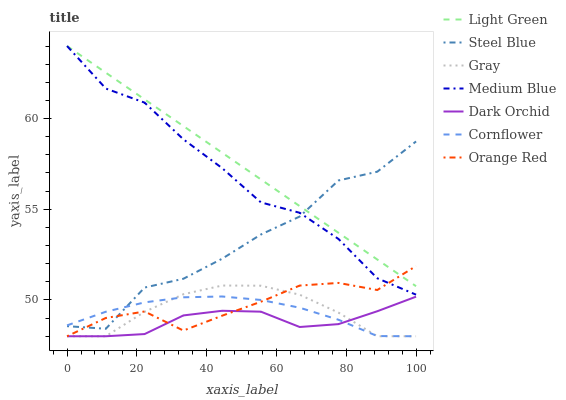Does Dark Orchid have the minimum area under the curve?
Answer yes or no. Yes. Does Light Green have the maximum area under the curve?
Answer yes or no. Yes. Does Cornflower have the minimum area under the curve?
Answer yes or no. No. Does Cornflower have the maximum area under the curve?
Answer yes or no. No. Is Light Green the smoothest?
Answer yes or no. Yes. Is Steel Blue the roughest?
Answer yes or no. Yes. Is Cornflower the smoothest?
Answer yes or no. No. Is Cornflower the roughest?
Answer yes or no. No. Does Gray have the lowest value?
Answer yes or no. Yes. Does Medium Blue have the lowest value?
Answer yes or no. No. Does Light Green have the highest value?
Answer yes or no. Yes. Does Cornflower have the highest value?
Answer yes or no. No. Is Gray less than Steel Blue?
Answer yes or no. Yes. Is Steel Blue greater than Dark Orchid?
Answer yes or no. Yes. Does Steel Blue intersect Orange Red?
Answer yes or no. Yes. Is Steel Blue less than Orange Red?
Answer yes or no. No. Is Steel Blue greater than Orange Red?
Answer yes or no. No. Does Gray intersect Steel Blue?
Answer yes or no. No. 